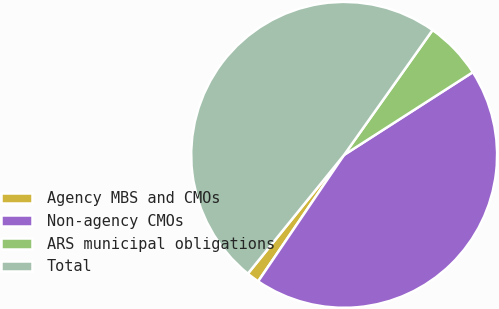Convert chart to OTSL. <chart><loc_0><loc_0><loc_500><loc_500><pie_chart><fcel>Agency MBS and CMOs<fcel>Non-agency CMOs<fcel>ARS municipal obligations<fcel>Total<nl><fcel>1.34%<fcel>43.59%<fcel>6.1%<fcel>48.97%<nl></chart> 